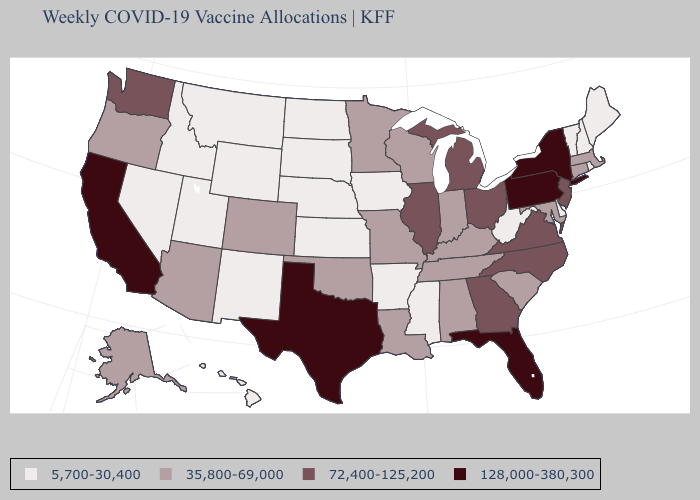Which states have the lowest value in the MidWest?
Be succinct. Iowa, Kansas, Nebraska, North Dakota, South Dakota. Does the map have missing data?
Write a very short answer. No. Name the states that have a value in the range 72,400-125,200?
Keep it brief. Georgia, Illinois, Michigan, New Jersey, North Carolina, Ohio, Virginia, Washington. Which states have the lowest value in the USA?
Keep it brief. Arkansas, Delaware, Hawaii, Idaho, Iowa, Kansas, Maine, Mississippi, Montana, Nebraska, Nevada, New Hampshire, New Mexico, North Dakota, Rhode Island, South Dakota, Utah, Vermont, West Virginia, Wyoming. What is the value of Texas?
Write a very short answer. 128,000-380,300. What is the lowest value in the MidWest?
Be succinct. 5,700-30,400. Does the first symbol in the legend represent the smallest category?
Keep it brief. Yes. Among the states that border Tennessee , which have the lowest value?
Quick response, please. Arkansas, Mississippi. What is the value of Utah?
Give a very brief answer. 5,700-30,400. Which states have the lowest value in the USA?
Give a very brief answer. Arkansas, Delaware, Hawaii, Idaho, Iowa, Kansas, Maine, Mississippi, Montana, Nebraska, Nevada, New Hampshire, New Mexico, North Dakota, Rhode Island, South Dakota, Utah, Vermont, West Virginia, Wyoming. Name the states that have a value in the range 128,000-380,300?
Write a very short answer. California, Florida, New York, Pennsylvania, Texas. Which states have the lowest value in the Northeast?
Concise answer only. Maine, New Hampshire, Rhode Island, Vermont. Does Maine have the highest value in the Northeast?
Concise answer only. No. What is the value of Hawaii?
Be succinct. 5,700-30,400. Name the states that have a value in the range 5,700-30,400?
Concise answer only. Arkansas, Delaware, Hawaii, Idaho, Iowa, Kansas, Maine, Mississippi, Montana, Nebraska, Nevada, New Hampshire, New Mexico, North Dakota, Rhode Island, South Dakota, Utah, Vermont, West Virginia, Wyoming. 